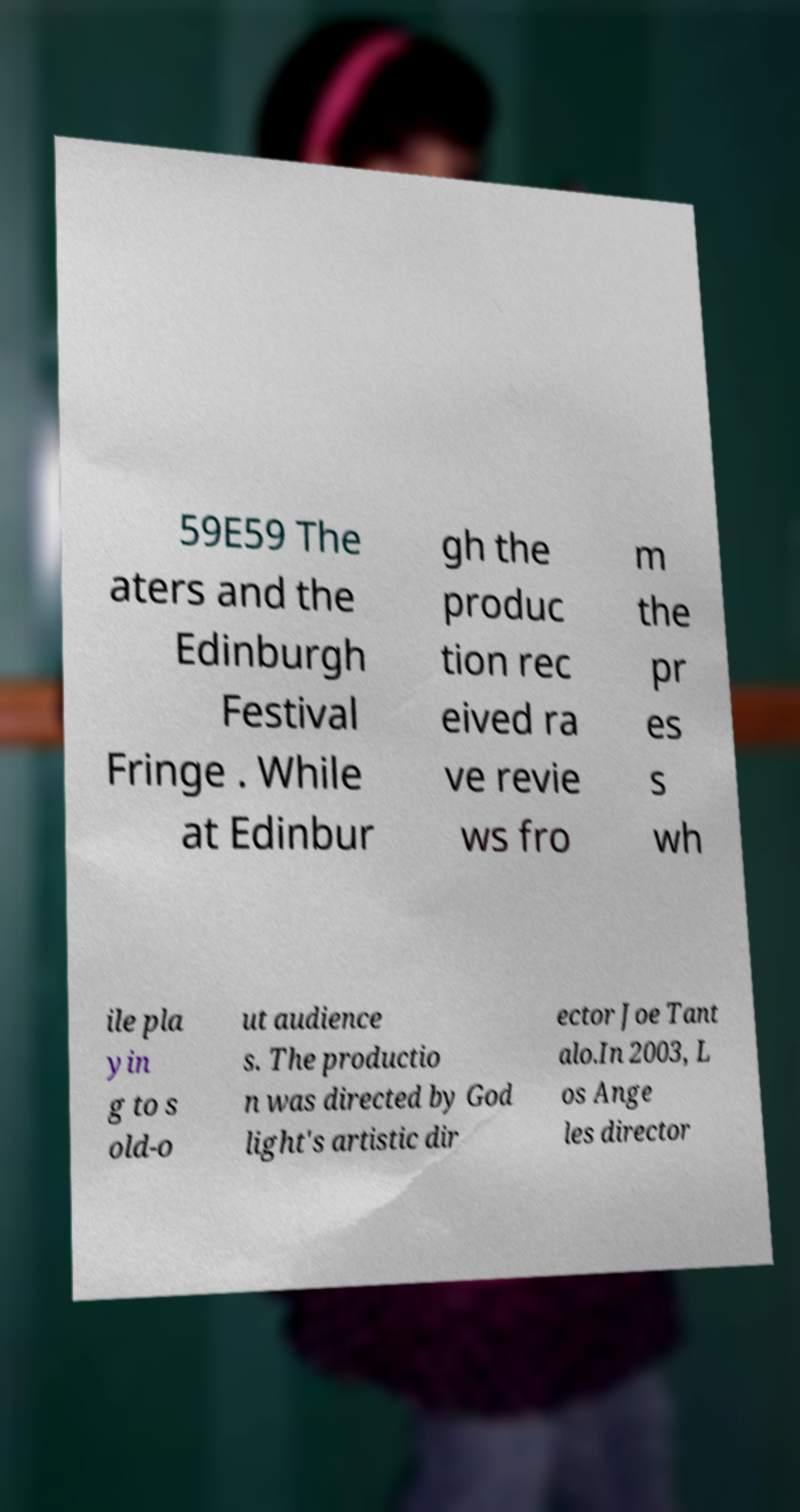Please read and relay the text visible in this image. What does it say? 59E59 The aters and the Edinburgh Festival Fringe . While at Edinbur gh the produc tion rec eived ra ve revie ws fro m the pr es s wh ile pla yin g to s old-o ut audience s. The productio n was directed by God light's artistic dir ector Joe Tant alo.In 2003, L os Ange les director 